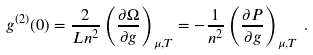<formula> <loc_0><loc_0><loc_500><loc_500>g ^ { ( 2 ) } ( 0 ) = \frac { 2 } { L n ^ { 2 } } \left ( \frac { \partial \Omega } { \partial g } \right ) _ { \mu , T } = - \frac { 1 } { n ^ { 2 } } \left ( \frac { \partial P } { \partial g } \right ) _ { \mu , T } \, .</formula> 